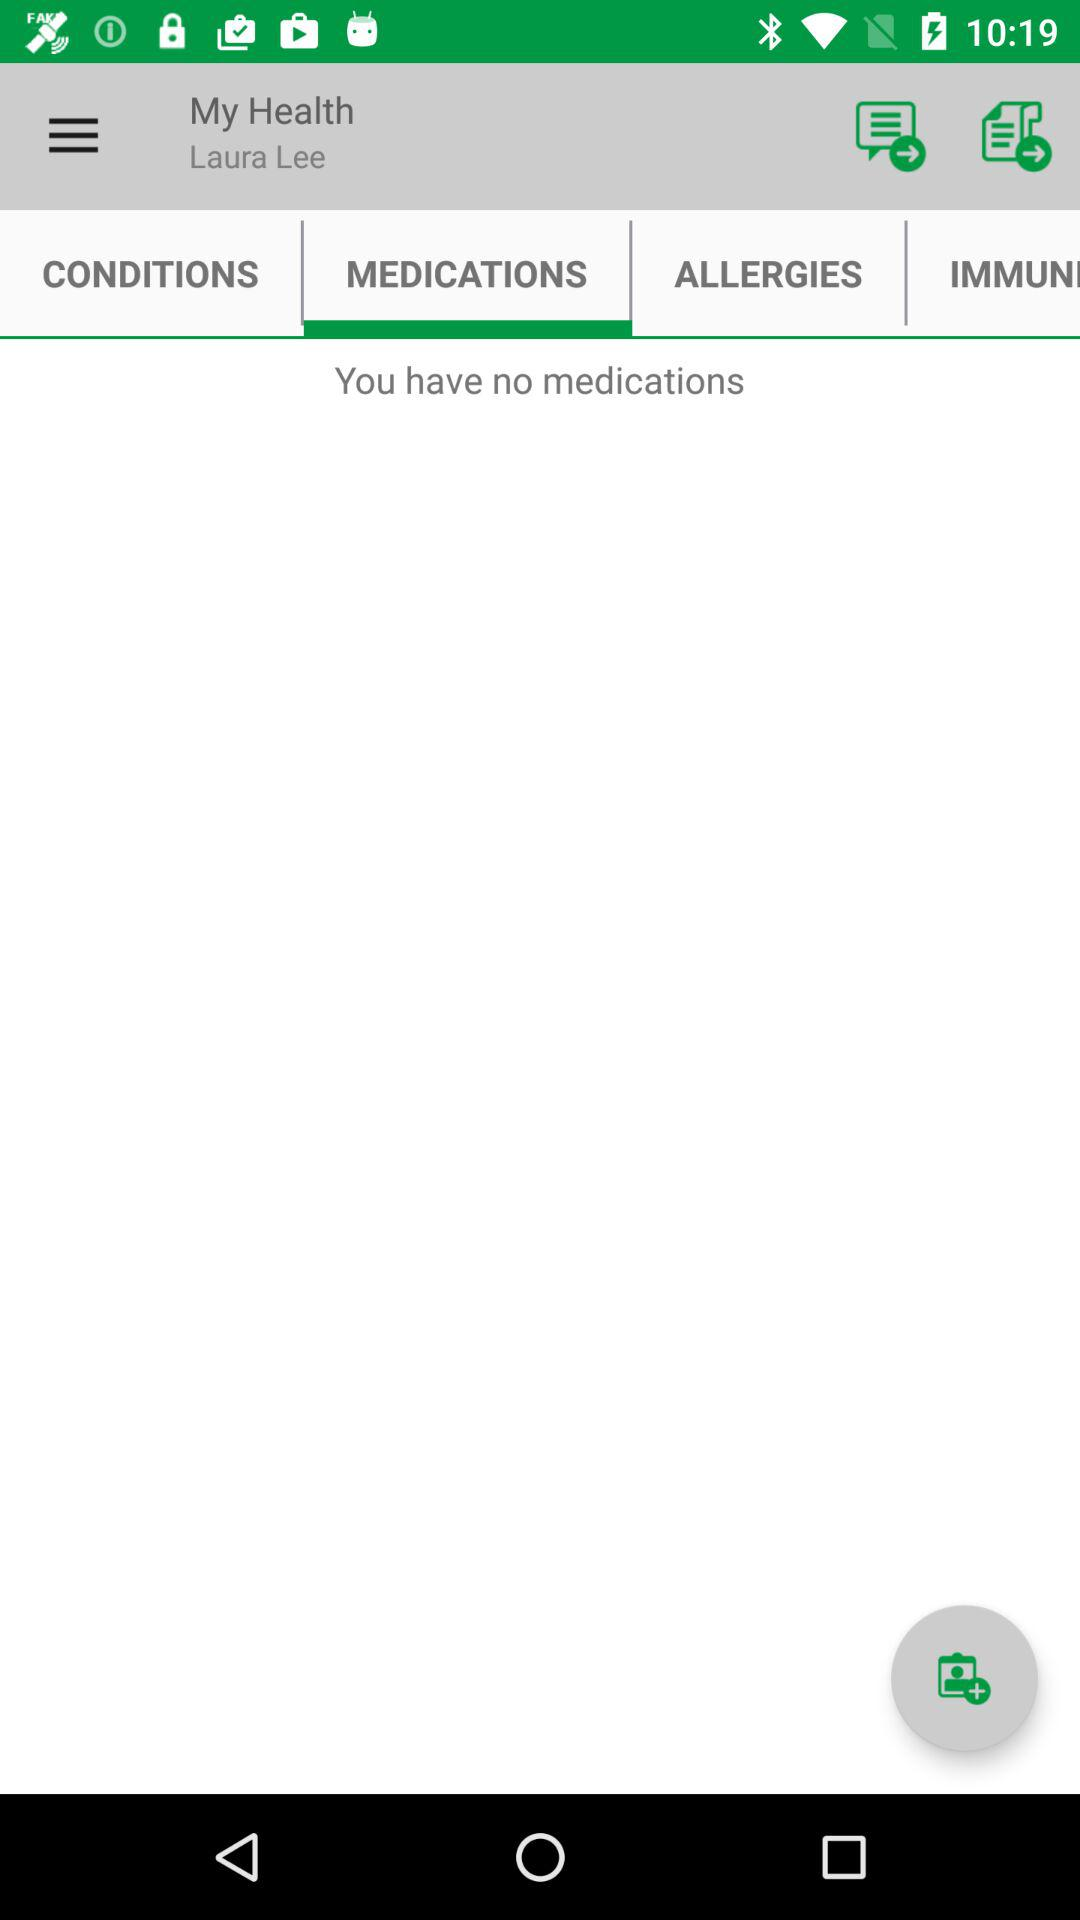What is the name of the user? The name of the user is Laura Lee. 